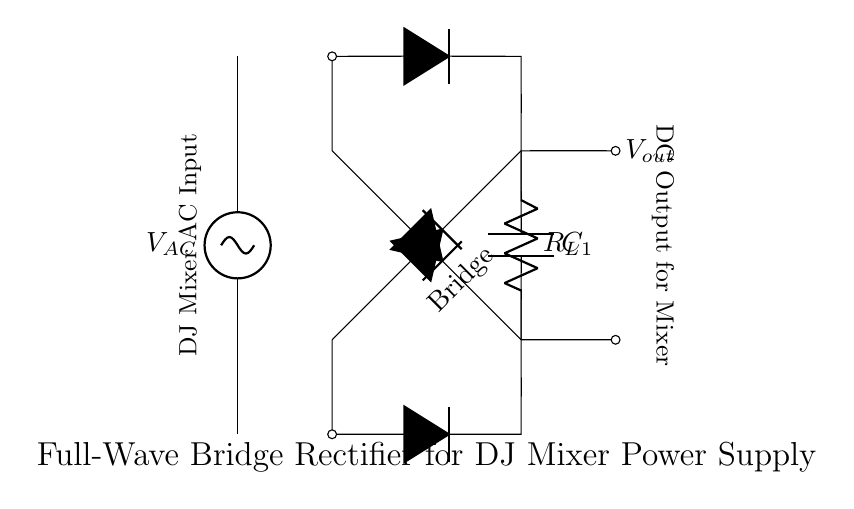What type of rectifier is shown in the diagram? The circuit diagram depicts a full-wave bridge rectifier, characterized by its arrangement of diodes to convert both halves of the AC input into DC output.
Answer: full-wave bridge rectifier What is the role of the smoothing capacitor? The smoothing capacitor is in place to reduce the ripple in the output voltage after rectification, ensuring a more constant and stable DC supply for optimal performance.
Answer: reduce ripple What is the output voltage type of this rectifier? The output voltage from this circuit is DC, as the bridge rectifier converts the alternating current from the AC source into direct current suitable for powering the DJ mixer.
Answer: DC How many diodes are used in the bridge rectifier? The bridge rectifier circuit consists of four diodes arranged in a bridge configuration, allowing current to flow in both directions during the AC cycle.
Answer: four What component is labeled as R_L in the circuit? R_L represents the load resistor within the circuit; it is where the DC voltage output is delivered, acting as a load for the power supply.
Answer: load resistor What is the connection configuration of the diodes in this rectifier? The diodes are connected in a bridge configuration, allowing the circuit to utilize both halves of the input AC waveform to create a continuous output.
Answer: bridge configuration Which component is responsible for filtering the output? The capacitor C_1 is responsible for filtering the output of the rectifier, smoothing the pulsating DC voltage to provide a more stable output for the load.
Answer: C_1 